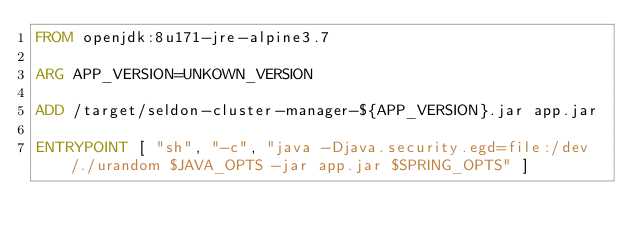Convert code to text. <code><loc_0><loc_0><loc_500><loc_500><_Dockerfile_>FROM openjdk:8u171-jre-alpine3.7

ARG APP_VERSION=UNKOWN_VERSION

ADD /target/seldon-cluster-manager-${APP_VERSION}.jar app.jar

ENTRYPOINT [ "sh", "-c", "java -Djava.security.egd=file:/dev/./urandom $JAVA_OPTS -jar app.jar $SPRING_OPTS" ]

</code> 